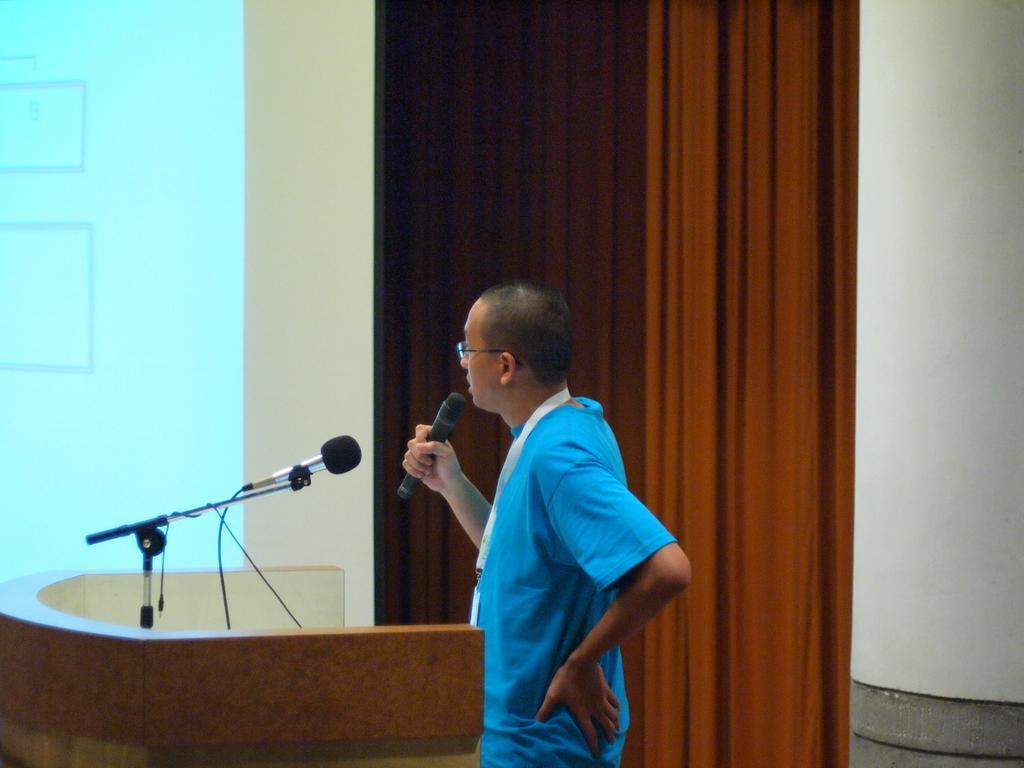Please provide a concise description of this image. In this picture we can see a man wore a spectacle and holding a mic with his hand and standing at the podium with a mic on it and in the background we can see screen. 